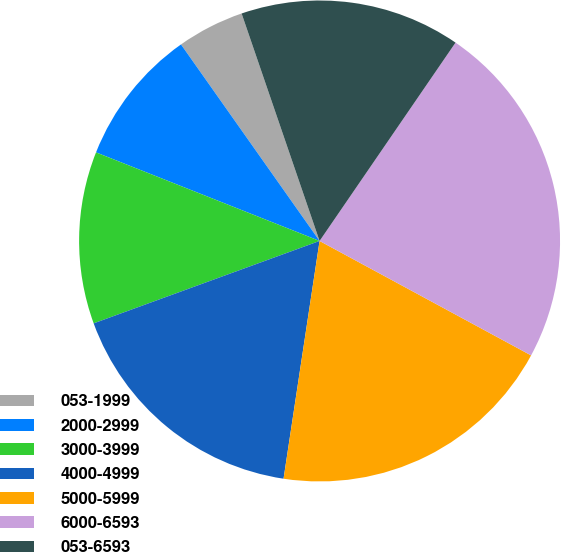Convert chart. <chart><loc_0><loc_0><loc_500><loc_500><pie_chart><fcel>053-1999<fcel>2000-2999<fcel>3000-3999<fcel>4000-4999<fcel>5000-5999<fcel>6000-6593<fcel>053-6593<nl><fcel>4.52%<fcel>9.22%<fcel>11.57%<fcel>17.04%<fcel>19.5%<fcel>23.33%<fcel>14.82%<nl></chart> 